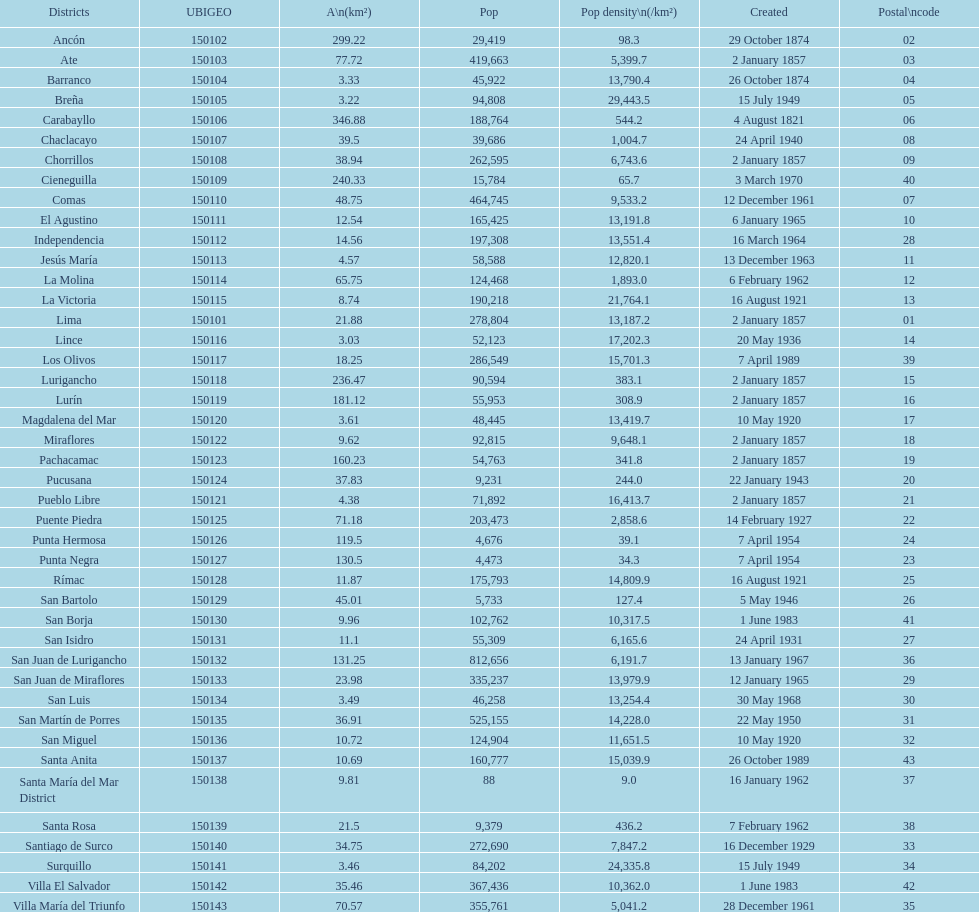How many districts have a population density of at lest 1000.0? 31. 